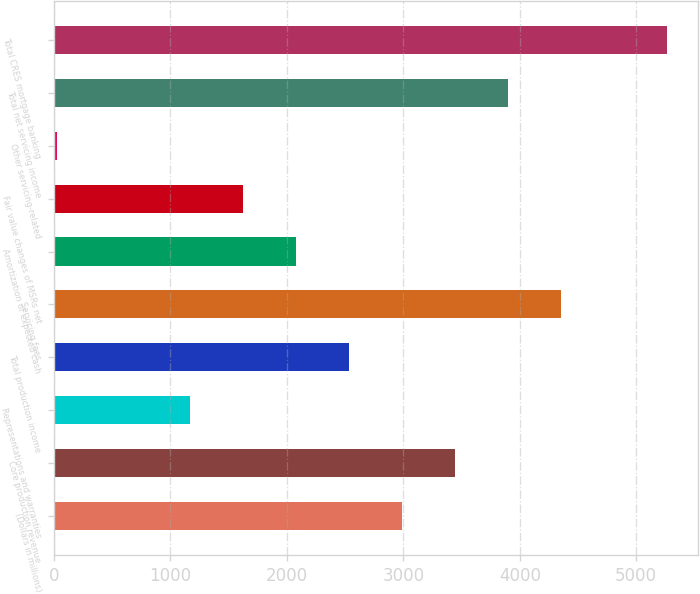Convert chart. <chart><loc_0><loc_0><loc_500><loc_500><bar_chart><fcel>(Dollars in millions)<fcel>Core production revenue<fcel>Representations and warranties<fcel>Total production income<fcel>Servicing fees<fcel>Amortization of expected cash<fcel>Fair value changes of MSRs net<fcel>Other servicing-related<fcel>Total net servicing income<fcel>Total CRES mortgage banking<nl><fcel>2989.5<fcel>3445.2<fcel>1166.7<fcel>2533.8<fcel>4356.6<fcel>2078.1<fcel>1622.4<fcel>28<fcel>3900.9<fcel>5268<nl></chart> 